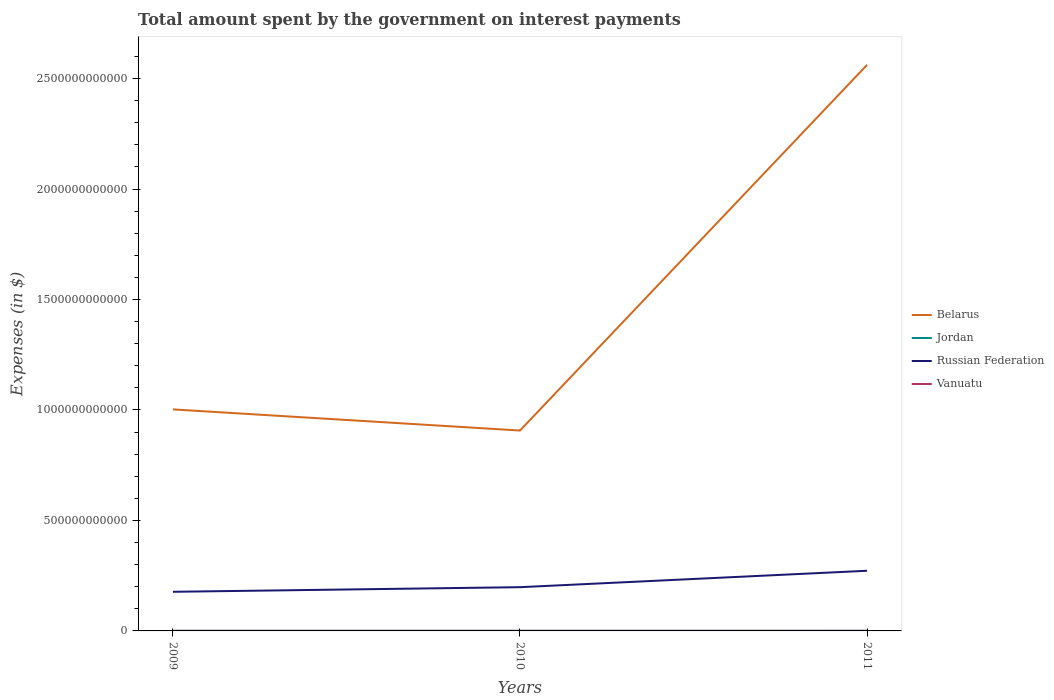Across all years, what is the maximum amount spent on interest payments by the government in Vanuatu?
Offer a terse response. 3.18e+08. In which year was the amount spent on interest payments by the government in Jordan maximum?
Ensure brevity in your answer.  2009. What is the total amount spent on interest payments by the government in Vanuatu in the graph?
Your answer should be very brief. -1.57e+07. What is the difference between the highest and the second highest amount spent on interest payments by the government in Jordan?
Ensure brevity in your answer.  3.73e+07. What is the difference between the highest and the lowest amount spent on interest payments by the government in Vanuatu?
Your response must be concise. 1. How many lines are there?
Keep it short and to the point. 4. How many years are there in the graph?
Offer a very short reply. 3. What is the difference between two consecutive major ticks on the Y-axis?
Ensure brevity in your answer.  5.00e+11. Are the values on the major ticks of Y-axis written in scientific E-notation?
Offer a very short reply. No. Does the graph contain grids?
Make the answer very short. No. How are the legend labels stacked?
Provide a short and direct response. Vertical. What is the title of the graph?
Ensure brevity in your answer.  Total amount spent by the government on interest payments. What is the label or title of the X-axis?
Your response must be concise. Years. What is the label or title of the Y-axis?
Provide a short and direct response. Expenses (in $). What is the Expenses (in $) in Belarus in 2009?
Provide a succinct answer. 1.00e+12. What is the Expenses (in $) of Jordan in 2009?
Provide a succinct answer. 3.92e+08. What is the Expenses (in $) in Russian Federation in 2009?
Ensure brevity in your answer.  1.77e+11. What is the Expenses (in $) of Vanuatu in 2009?
Provide a short and direct response. 3.18e+08. What is the Expenses (in $) in Belarus in 2010?
Your answer should be very brief. 9.07e+11. What is the Expenses (in $) in Jordan in 2010?
Give a very brief answer. 3.98e+08. What is the Expenses (in $) of Russian Federation in 2010?
Your answer should be compact. 1.98e+11. What is the Expenses (in $) in Vanuatu in 2010?
Offer a very short reply. 3.34e+08. What is the Expenses (in $) of Belarus in 2011?
Give a very brief answer. 2.56e+12. What is the Expenses (in $) in Jordan in 2011?
Offer a terse response. 4.30e+08. What is the Expenses (in $) in Russian Federation in 2011?
Give a very brief answer. 2.72e+11. What is the Expenses (in $) of Vanuatu in 2011?
Provide a short and direct response. 4.68e+08. Across all years, what is the maximum Expenses (in $) in Belarus?
Provide a short and direct response. 2.56e+12. Across all years, what is the maximum Expenses (in $) of Jordan?
Your response must be concise. 4.30e+08. Across all years, what is the maximum Expenses (in $) of Russian Federation?
Your answer should be compact. 2.72e+11. Across all years, what is the maximum Expenses (in $) of Vanuatu?
Offer a very short reply. 4.68e+08. Across all years, what is the minimum Expenses (in $) of Belarus?
Your response must be concise. 9.07e+11. Across all years, what is the minimum Expenses (in $) of Jordan?
Offer a terse response. 3.92e+08. Across all years, what is the minimum Expenses (in $) of Russian Federation?
Ensure brevity in your answer.  1.77e+11. Across all years, what is the minimum Expenses (in $) of Vanuatu?
Your response must be concise. 3.18e+08. What is the total Expenses (in $) of Belarus in the graph?
Make the answer very short. 4.47e+12. What is the total Expenses (in $) of Jordan in the graph?
Keep it short and to the point. 1.22e+09. What is the total Expenses (in $) of Russian Federation in the graph?
Offer a very short reply. 6.47e+11. What is the total Expenses (in $) of Vanuatu in the graph?
Provide a succinct answer. 1.12e+09. What is the difference between the Expenses (in $) of Belarus in 2009 and that in 2010?
Keep it short and to the point. 9.56e+1. What is the difference between the Expenses (in $) in Jordan in 2009 and that in 2010?
Your response must be concise. -5.30e+06. What is the difference between the Expenses (in $) of Russian Federation in 2009 and that in 2010?
Make the answer very short. -2.09e+1. What is the difference between the Expenses (in $) in Vanuatu in 2009 and that in 2010?
Provide a succinct answer. -1.57e+07. What is the difference between the Expenses (in $) of Belarus in 2009 and that in 2011?
Offer a very short reply. -1.56e+12. What is the difference between the Expenses (in $) in Jordan in 2009 and that in 2011?
Ensure brevity in your answer.  -3.73e+07. What is the difference between the Expenses (in $) of Russian Federation in 2009 and that in 2011?
Give a very brief answer. -9.52e+1. What is the difference between the Expenses (in $) in Vanuatu in 2009 and that in 2011?
Your answer should be very brief. -1.50e+08. What is the difference between the Expenses (in $) in Belarus in 2010 and that in 2011?
Provide a short and direct response. -1.66e+12. What is the difference between the Expenses (in $) in Jordan in 2010 and that in 2011?
Provide a succinct answer. -3.20e+07. What is the difference between the Expenses (in $) of Russian Federation in 2010 and that in 2011?
Provide a succinct answer. -7.43e+1. What is the difference between the Expenses (in $) of Vanuatu in 2010 and that in 2011?
Your response must be concise. -1.34e+08. What is the difference between the Expenses (in $) in Belarus in 2009 and the Expenses (in $) in Jordan in 2010?
Offer a terse response. 1.00e+12. What is the difference between the Expenses (in $) in Belarus in 2009 and the Expenses (in $) in Russian Federation in 2010?
Offer a terse response. 8.05e+11. What is the difference between the Expenses (in $) in Belarus in 2009 and the Expenses (in $) in Vanuatu in 2010?
Provide a succinct answer. 1.00e+12. What is the difference between the Expenses (in $) of Jordan in 2009 and the Expenses (in $) of Russian Federation in 2010?
Provide a short and direct response. -1.98e+11. What is the difference between the Expenses (in $) of Jordan in 2009 and the Expenses (in $) of Vanuatu in 2010?
Offer a terse response. 5.87e+07. What is the difference between the Expenses (in $) in Russian Federation in 2009 and the Expenses (in $) in Vanuatu in 2010?
Make the answer very short. 1.77e+11. What is the difference between the Expenses (in $) in Belarus in 2009 and the Expenses (in $) in Jordan in 2011?
Your answer should be compact. 1.00e+12. What is the difference between the Expenses (in $) in Belarus in 2009 and the Expenses (in $) in Russian Federation in 2011?
Ensure brevity in your answer.  7.30e+11. What is the difference between the Expenses (in $) in Belarus in 2009 and the Expenses (in $) in Vanuatu in 2011?
Make the answer very short. 1.00e+12. What is the difference between the Expenses (in $) of Jordan in 2009 and the Expenses (in $) of Russian Federation in 2011?
Offer a very short reply. -2.72e+11. What is the difference between the Expenses (in $) in Jordan in 2009 and the Expenses (in $) in Vanuatu in 2011?
Offer a terse response. -7.53e+07. What is the difference between the Expenses (in $) in Russian Federation in 2009 and the Expenses (in $) in Vanuatu in 2011?
Your response must be concise. 1.77e+11. What is the difference between the Expenses (in $) of Belarus in 2010 and the Expenses (in $) of Jordan in 2011?
Give a very brief answer. 9.07e+11. What is the difference between the Expenses (in $) of Belarus in 2010 and the Expenses (in $) of Russian Federation in 2011?
Ensure brevity in your answer.  6.35e+11. What is the difference between the Expenses (in $) in Belarus in 2010 and the Expenses (in $) in Vanuatu in 2011?
Provide a short and direct response. 9.07e+11. What is the difference between the Expenses (in $) in Jordan in 2010 and the Expenses (in $) in Russian Federation in 2011?
Ensure brevity in your answer.  -2.72e+11. What is the difference between the Expenses (in $) in Jordan in 2010 and the Expenses (in $) in Vanuatu in 2011?
Make the answer very short. -7.00e+07. What is the difference between the Expenses (in $) in Russian Federation in 2010 and the Expenses (in $) in Vanuatu in 2011?
Provide a succinct answer. 1.98e+11. What is the average Expenses (in $) of Belarus per year?
Make the answer very short. 1.49e+12. What is the average Expenses (in $) in Jordan per year?
Your response must be concise. 4.06e+08. What is the average Expenses (in $) in Russian Federation per year?
Your answer should be compact. 2.16e+11. What is the average Expenses (in $) in Vanuatu per year?
Offer a terse response. 3.73e+08. In the year 2009, what is the difference between the Expenses (in $) of Belarus and Expenses (in $) of Jordan?
Your answer should be compact. 1.00e+12. In the year 2009, what is the difference between the Expenses (in $) in Belarus and Expenses (in $) in Russian Federation?
Make the answer very short. 8.26e+11. In the year 2009, what is the difference between the Expenses (in $) of Belarus and Expenses (in $) of Vanuatu?
Ensure brevity in your answer.  1.00e+12. In the year 2009, what is the difference between the Expenses (in $) of Jordan and Expenses (in $) of Russian Federation?
Offer a very short reply. -1.77e+11. In the year 2009, what is the difference between the Expenses (in $) of Jordan and Expenses (in $) of Vanuatu?
Keep it short and to the point. 7.44e+07. In the year 2009, what is the difference between the Expenses (in $) in Russian Federation and Expenses (in $) in Vanuatu?
Ensure brevity in your answer.  1.77e+11. In the year 2010, what is the difference between the Expenses (in $) of Belarus and Expenses (in $) of Jordan?
Offer a very short reply. 9.07e+11. In the year 2010, what is the difference between the Expenses (in $) in Belarus and Expenses (in $) in Russian Federation?
Make the answer very short. 7.09e+11. In the year 2010, what is the difference between the Expenses (in $) in Belarus and Expenses (in $) in Vanuatu?
Offer a very short reply. 9.07e+11. In the year 2010, what is the difference between the Expenses (in $) in Jordan and Expenses (in $) in Russian Federation?
Make the answer very short. -1.98e+11. In the year 2010, what is the difference between the Expenses (in $) of Jordan and Expenses (in $) of Vanuatu?
Your answer should be very brief. 6.40e+07. In the year 2010, what is the difference between the Expenses (in $) in Russian Federation and Expenses (in $) in Vanuatu?
Provide a succinct answer. 1.98e+11. In the year 2011, what is the difference between the Expenses (in $) in Belarus and Expenses (in $) in Jordan?
Provide a succinct answer. 2.56e+12. In the year 2011, what is the difference between the Expenses (in $) of Belarus and Expenses (in $) of Russian Federation?
Provide a succinct answer. 2.29e+12. In the year 2011, what is the difference between the Expenses (in $) in Belarus and Expenses (in $) in Vanuatu?
Ensure brevity in your answer.  2.56e+12. In the year 2011, what is the difference between the Expenses (in $) of Jordan and Expenses (in $) of Russian Federation?
Ensure brevity in your answer.  -2.72e+11. In the year 2011, what is the difference between the Expenses (in $) in Jordan and Expenses (in $) in Vanuatu?
Provide a succinct answer. -3.80e+07. In the year 2011, what is the difference between the Expenses (in $) in Russian Federation and Expenses (in $) in Vanuatu?
Ensure brevity in your answer.  2.72e+11. What is the ratio of the Expenses (in $) in Belarus in 2009 to that in 2010?
Keep it short and to the point. 1.11. What is the ratio of the Expenses (in $) of Jordan in 2009 to that in 2010?
Your answer should be compact. 0.99. What is the ratio of the Expenses (in $) in Russian Federation in 2009 to that in 2010?
Ensure brevity in your answer.  0.89. What is the ratio of the Expenses (in $) in Vanuatu in 2009 to that in 2010?
Keep it short and to the point. 0.95. What is the ratio of the Expenses (in $) of Belarus in 2009 to that in 2011?
Your answer should be compact. 0.39. What is the ratio of the Expenses (in $) of Jordan in 2009 to that in 2011?
Offer a very short reply. 0.91. What is the ratio of the Expenses (in $) of Russian Federation in 2009 to that in 2011?
Offer a terse response. 0.65. What is the ratio of the Expenses (in $) in Vanuatu in 2009 to that in 2011?
Provide a succinct answer. 0.68. What is the ratio of the Expenses (in $) in Belarus in 2010 to that in 2011?
Ensure brevity in your answer.  0.35. What is the ratio of the Expenses (in $) of Jordan in 2010 to that in 2011?
Give a very brief answer. 0.93. What is the ratio of the Expenses (in $) of Russian Federation in 2010 to that in 2011?
Make the answer very short. 0.73. What is the ratio of the Expenses (in $) of Vanuatu in 2010 to that in 2011?
Your response must be concise. 0.71. What is the difference between the highest and the second highest Expenses (in $) of Belarus?
Keep it short and to the point. 1.56e+12. What is the difference between the highest and the second highest Expenses (in $) of Jordan?
Make the answer very short. 3.20e+07. What is the difference between the highest and the second highest Expenses (in $) of Russian Federation?
Make the answer very short. 7.43e+1. What is the difference between the highest and the second highest Expenses (in $) in Vanuatu?
Give a very brief answer. 1.34e+08. What is the difference between the highest and the lowest Expenses (in $) of Belarus?
Provide a succinct answer. 1.66e+12. What is the difference between the highest and the lowest Expenses (in $) in Jordan?
Offer a terse response. 3.73e+07. What is the difference between the highest and the lowest Expenses (in $) of Russian Federation?
Your response must be concise. 9.52e+1. What is the difference between the highest and the lowest Expenses (in $) in Vanuatu?
Provide a succinct answer. 1.50e+08. 